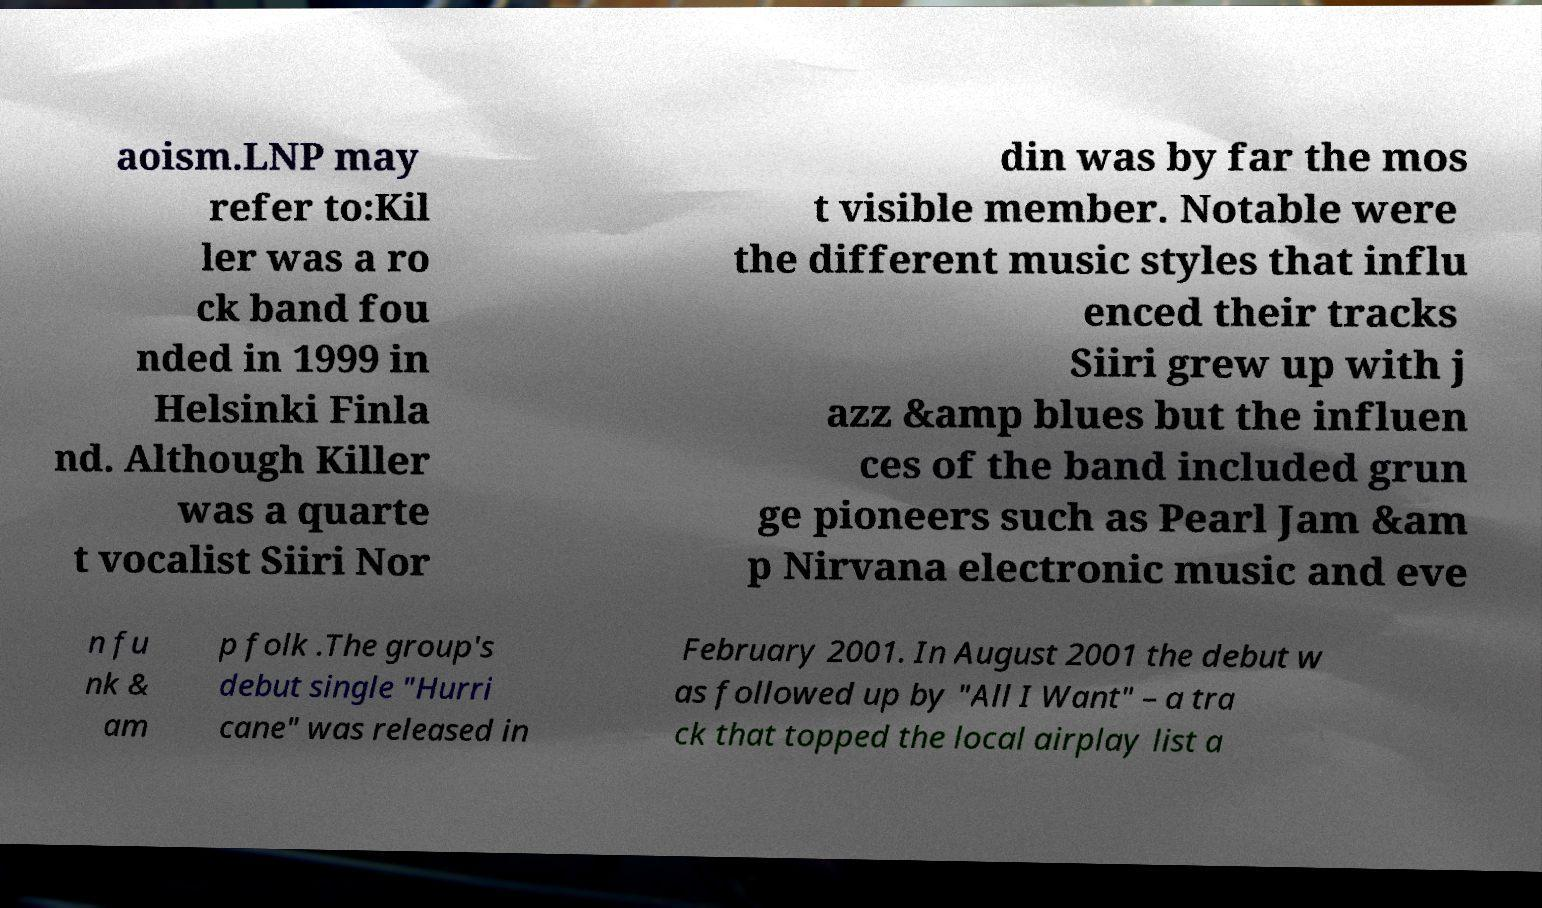Could you assist in decoding the text presented in this image and type it out clearly? aoism.LNP may refer to:Kil ler was a ro ck band fou nded in 1999 in Helsinki Finla nd. Although Killer was a quarte t vocalist Siiri Nor din was by far the mos t visible member. Notable were the different music styles that influ enced their tracks Siiri grew up with j azz &amp blues but the influen ces of the band included grun ge pioneers such as Pearl Jam &am p Nirvana electronic music and eve n fu nk & am p folk .The group's debut single "Hurri cane" was released in February 2001. In August 2001 the debut w as followed up by "All I Want" – a tra ck that topped the local airplay list a 